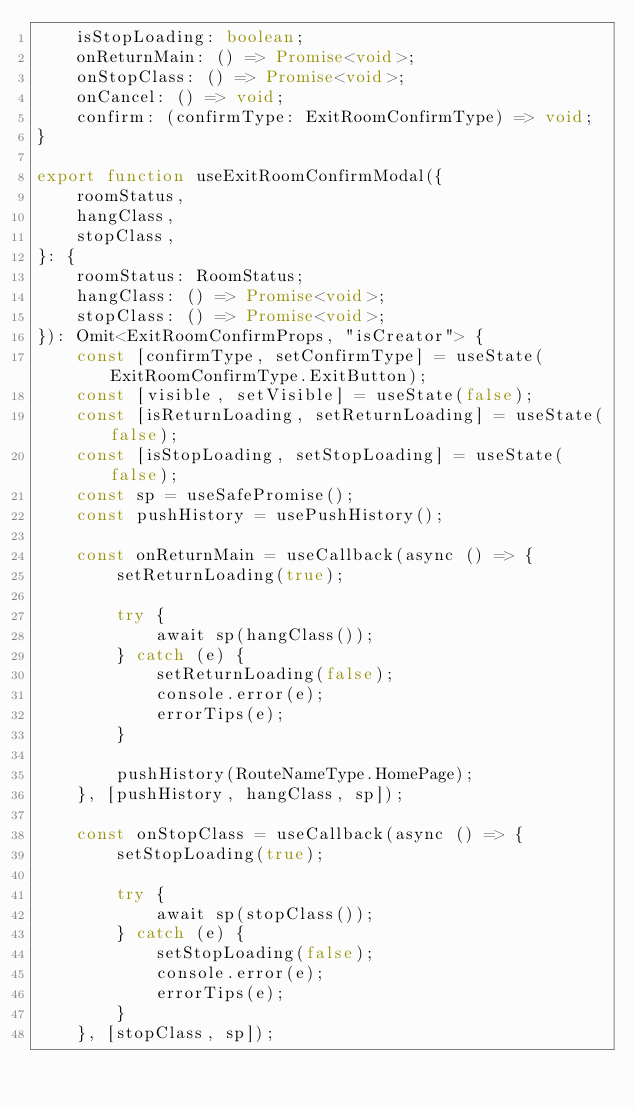Convert code to text. <code><loc_0><loc_0><loc_500><loc_500><_TypeScript_>    isStopLoading: boolean;
    onReturnMain: () => Promise<void>;
    onStopClass: () => Promise<void>;
    onCancel: () => void;
    confirm: (confirmType: ExitRoomConfirmType) => void;
}

export function useExitRoomConfirmModal({
    roomStatus,
    hangClass,
    stopClass,
}: {
    roomStatus: RoomStatus;
    hangClass: () => Promise<void>;
    stopClass: () => Promise<void>;
}): Omit<ExitRoomConfirmProps, "isCreator"> {
    const [confirmType, setConfirmType] = useState(ExitRoomConfirmType.ExitButton);
    const [visible, setVisible] = useState(false);
    const [isReturnLoading, setReturnLoading] = useState(false);
    const [isStopLoading, setStopLoading] = useState(false);
    const sp = useSafePromise();
    const pushHistory = usePushHistory();

    const onReturnMain = useCallback(async () => {
        setReturnLoading(true);

        try {
            await sp(hangClass());
        } catch (e) {
            setReturnLoading(false);
            console.error(e);
            errorTips(e);
        }

        pushHistory(RouteNameType.HomePage);
    }, [pushHistory, hangClass, sp]);

    const onStopClass = useCallback(async () => {
        setStopLoading(true);

        try {
            await sp(stopClass());
        } catch (e) {
            setStopLoading(false);
            console.error(e);
            errorTips(e);
        }
    }, [stopClass, sp]);
</code> 